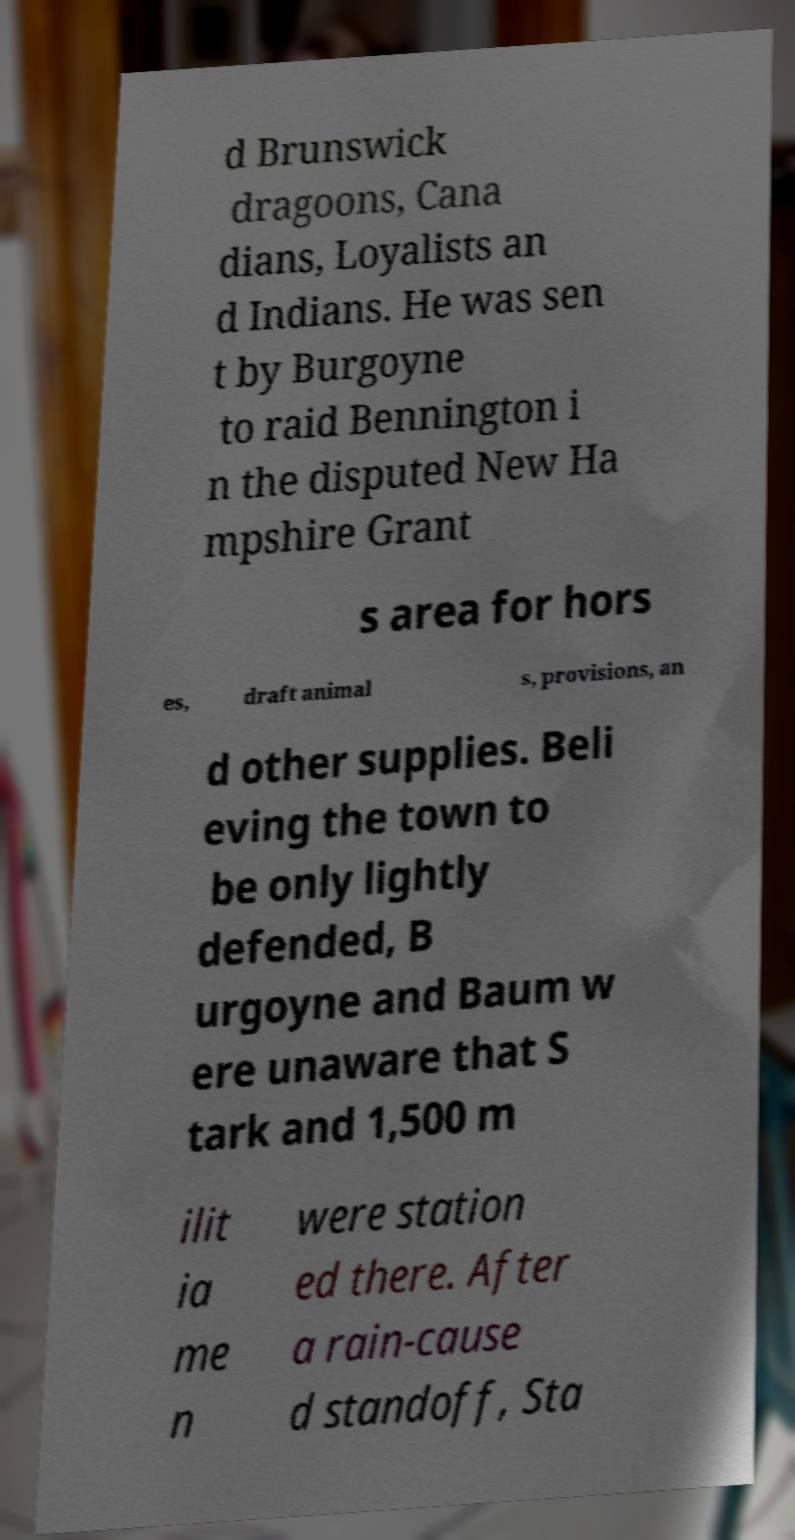Can you accurately transcribe the text from the provided image for me? d Brunswick dragoons, Cana dians, Loyalists an d Indians. He was sen t by Burgoyne to raid Bennington i n the disputed New Ha mpshire Grant s area for hors es, draft animal s, provisions, an d other supplies. Beli eving the town to be only lightly defended, B urgoyne and Baum w ere unaware that S tark and 1,500 m ilit ia me n were station ed there. After a rain-cause d standoff, Sta 